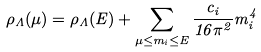Convert formula to latex. <formula><loc_0><loc_0><loc_500><loc_500>\rho _ { \Lambda } ( \mu ) = \rho _ { \Lambda } ( E ) + \sum _ { \mu \leq m _ { i } \leq E } \frac { c _ { i } } { 1 6 \pi ^ { 2 } } m _ { i } ^ { 4 }</formula> 